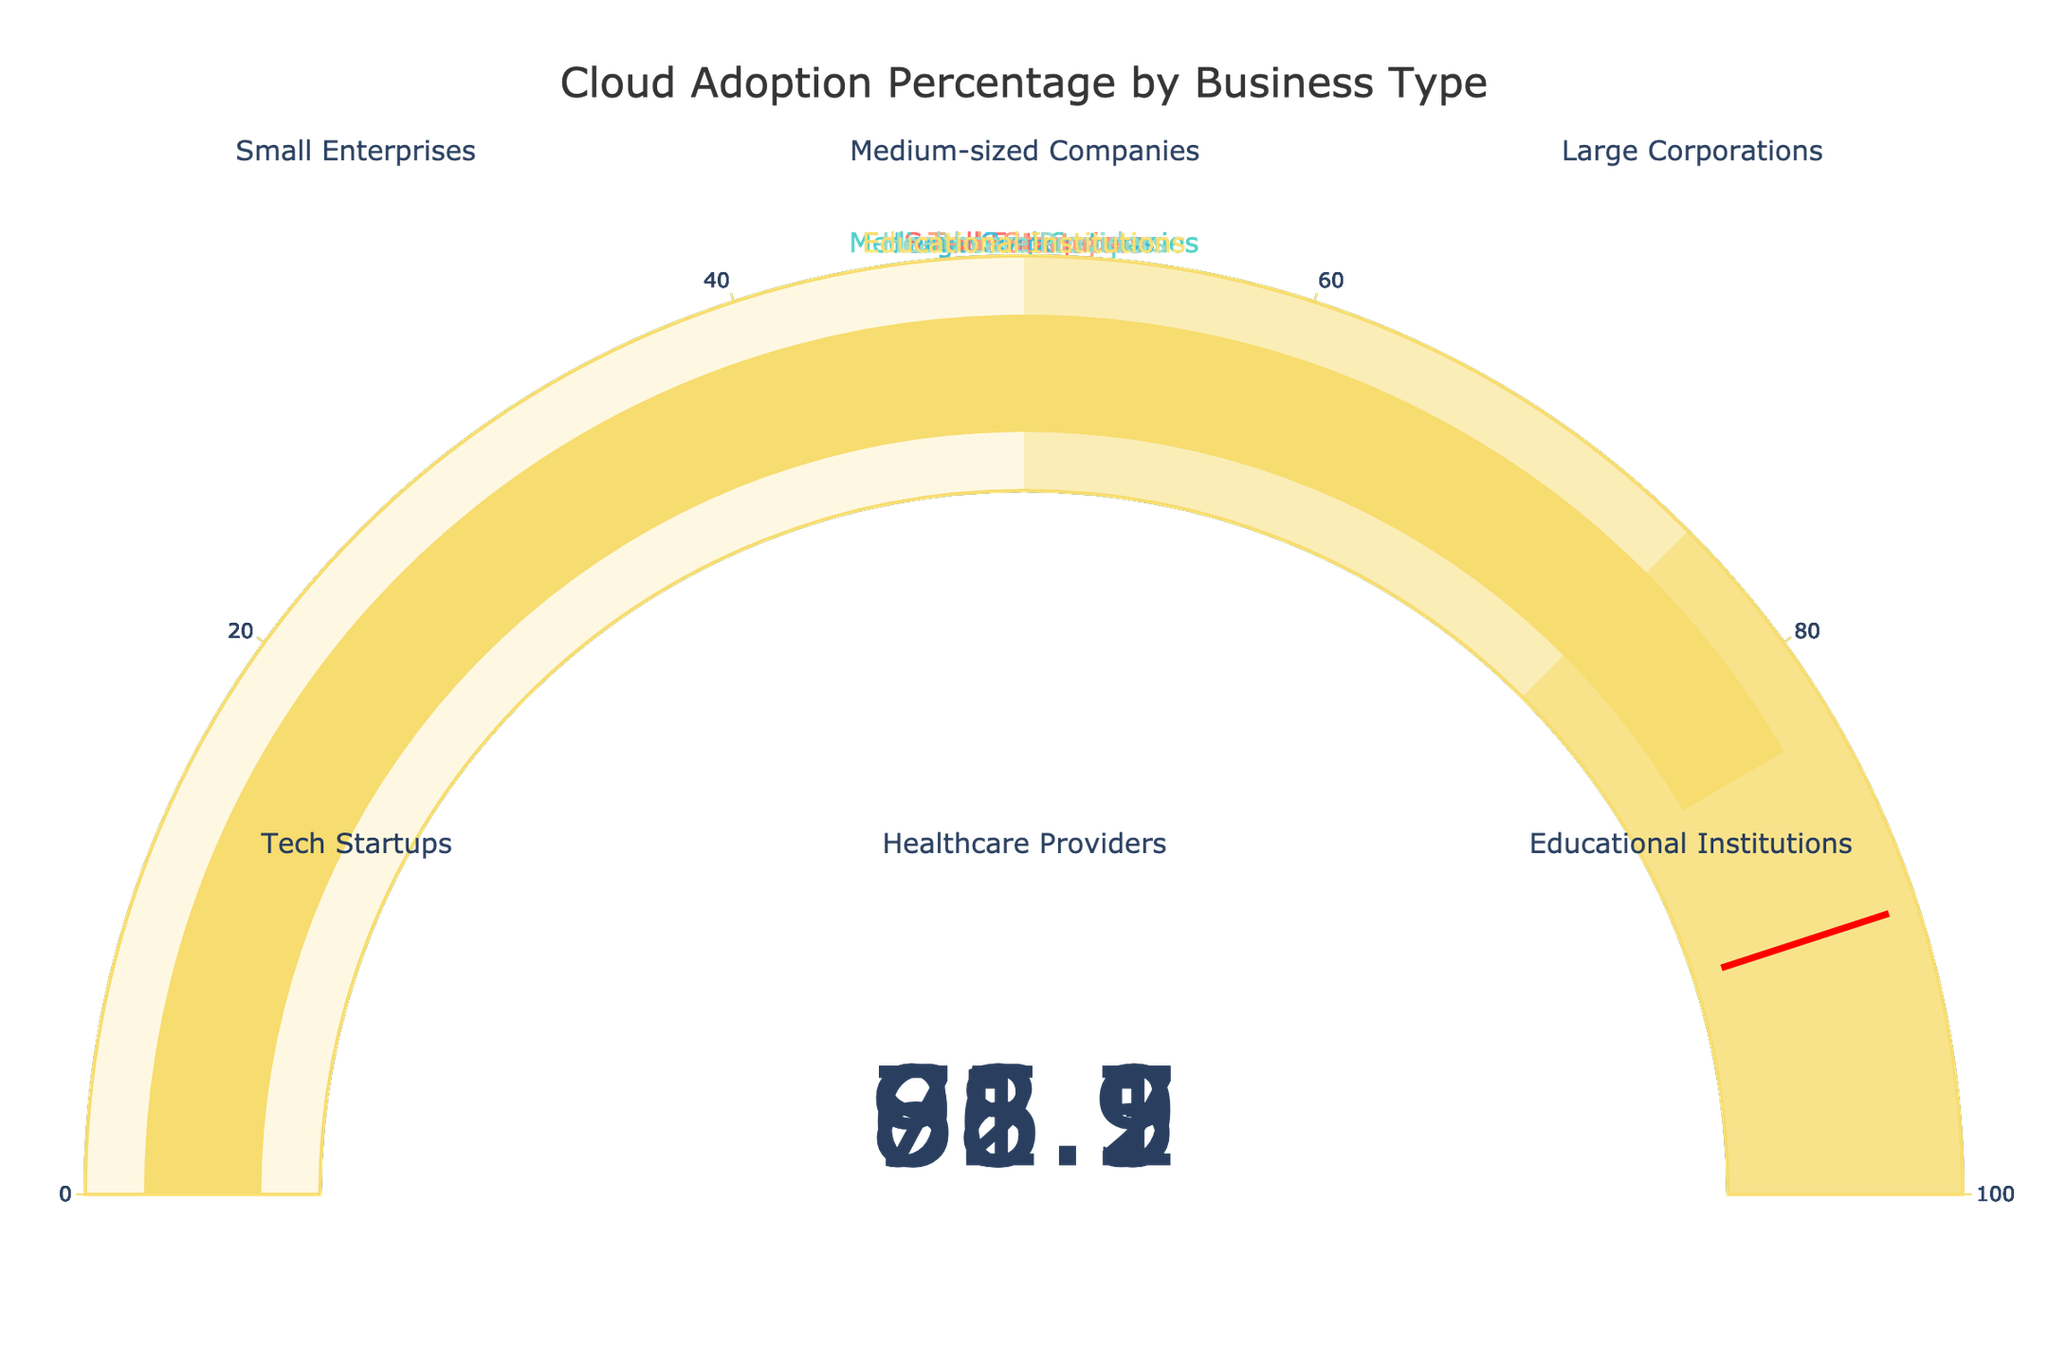What is the cloud adoption percentage for tech startups? Look at the gauge chart labeled "Tech Startups" and read the displayed number. The cloud adoption percentage for tech startups is 96.7%.
Answer: 96.7% Which business type has the lowest cloud adoption percentage? Compare all gauge charts and identify the business type with the smallest number. "Small Enterprises" have the lowest cloud adoption percentage at 65.3%.
Answer: Small Enterprises What is the average cloud adoption percentage across all business types? Sum all the cloud adoption percentages and then divide by the total number of business types. (65.3 + 78.9 + 92.1 + 96.7 + 71.5 + 83.2) / 6 = 81.2833. So, the average is approximately 81.3%.
Answer: 81.3% Is the cloud adoption percentage for healthcare providers greater than that for small enterprises? Compare the displayed cloud adoption percentages for "Healthcare Providers" and "Small Enterprises". Healthcare Providers (71.5%) have a higher percentage than Small Enterprises (65.3%).
Answer: Yes Which two business types have the closest cloud adoption percentages? Determine the two business types with the smallest difference in their percentages. "Healthcare Providers" (71.5%) and "Small Enterprises" (65.3%) have the closest percentages with a difference of 6.2%.
Answer: Healthcare Providers and Small Enterprises What is the difference in cloud adoption percentage between large corporations and medium-sized companies? Subtract the percentage of medium-sized companies from that of large corporations. 92.1% (Large Corporations) - 78.9% (Medium-sized Companies) = 13.2%.
Answer: 13.2% How many business types have a cloud adoption percentage above 80%? Count the number of gauge charts displaying percentages above 80%. There are 3: Large Corporations, Tech Startups, and Educational Institutions.
Answer: 3 Does any business type have a cloud adoption percentage below 70%? Identify if any of the displayed numbers on the gauge charts are below 70%. Only "Small Enterprises" at 65.3% are below 70%.
Answer: Yes Which business type's cloud adoption percentage is closest to the threshold line value of 90? Compare the percentages to the threshold line value and find the closest one. "Large Corporations" at 92.1% are closest to 90.
Answer: Large Corporations What is the range for the gauge chart of educational institutions? Read the number displayed on the educational institutions' gauge. "Educational Institutions" have a cloud adoption percentage of 83.2%, within the gauge's range of 0 to 100.
Answer: 0 to 100 